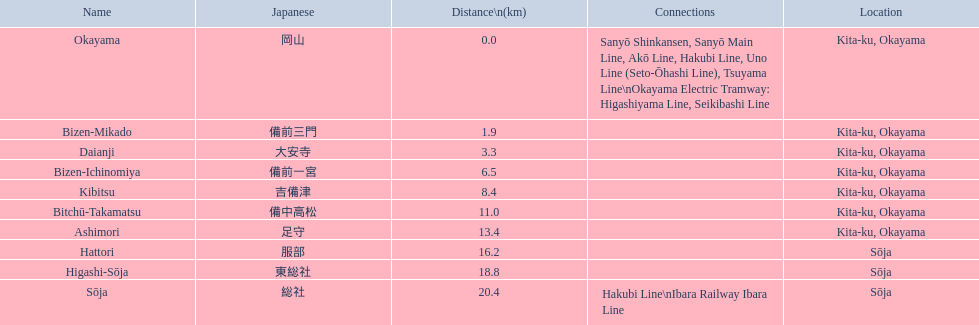How many continuous stops do you have to go through when boarding the kibi line at bizen-mikado and leaving at kibitsu? 2. 